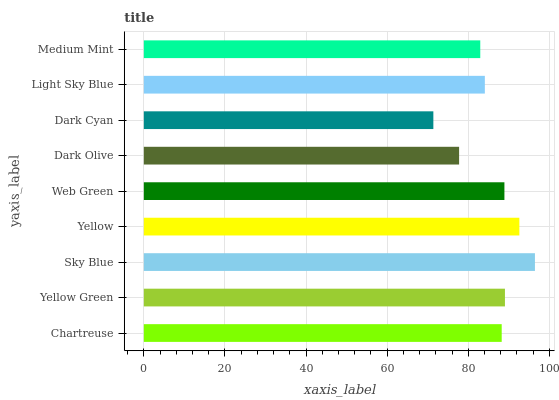Is Dark Cyan the minimum?
Answer yes or no. Yes. Is Sky Blue the maximum?
Answer yes or no. Yes. Is Yellow Green the minimum?
Answer yes or no. No. Is Yellow Green the maximum?
Answer yes or no. No. Is Yellow Green greater than Chartreuse?
Answer yes or no. Yes. Is Chartreuse less than Yellow Green?
Answer yes or no. Yes. Is Chartreuse greater than Yellow Green?
Answer yes or no. No. Is Yellow Green less than Chartreuse?
Answer yes or no. No. Is Chartreuse the high median?
Answer yes or no. Yes. Is Chartreuse the low median?
Answer yes or no. Yes. Is Dark Olive the high median?
Answer yes or no. No. Is Medium Mint the low median?
Answer yes or no. No. 